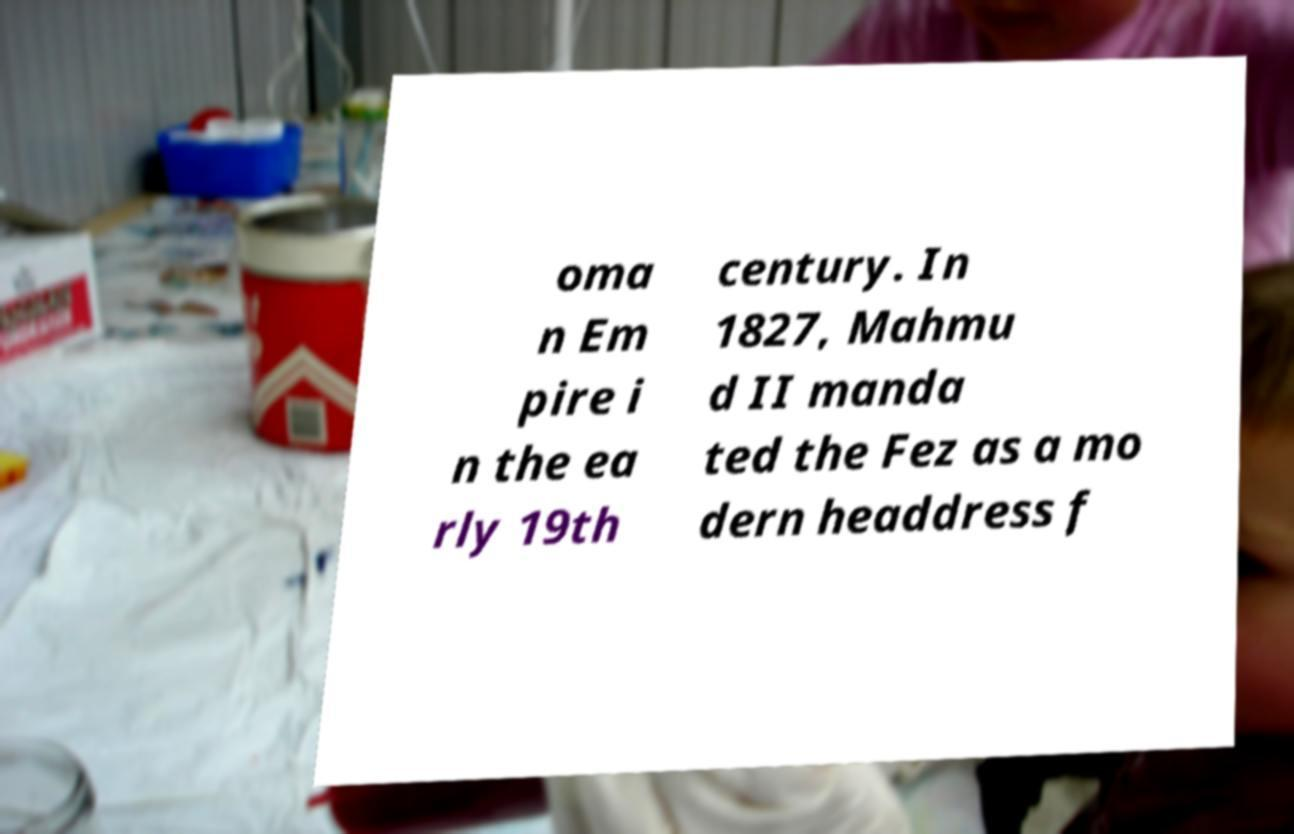For documentation purposes, I need the text within this image transcribed. Could you provide that? oma n Em pire i n the ea rly 19th century. In 1827, Mahmu d II manda ted the Fez as a mo dern headdress f 